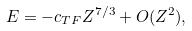Convert formula to latex. <formula><loc_0><loc_0><loc_500><loc_500>E = - c _ { T F } Z ^ { 7 / 3 } + O ( Z ^ { 2 } ) ,</formula> 